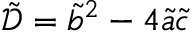Convert formula to latex. <formula><loc_0><loc_0><loc_500><loc_500>\tilde { \mathcal { D } } = \tilde { b } ^ { 2 } - 4 \tilde { a } \tilde { c }</formula> 